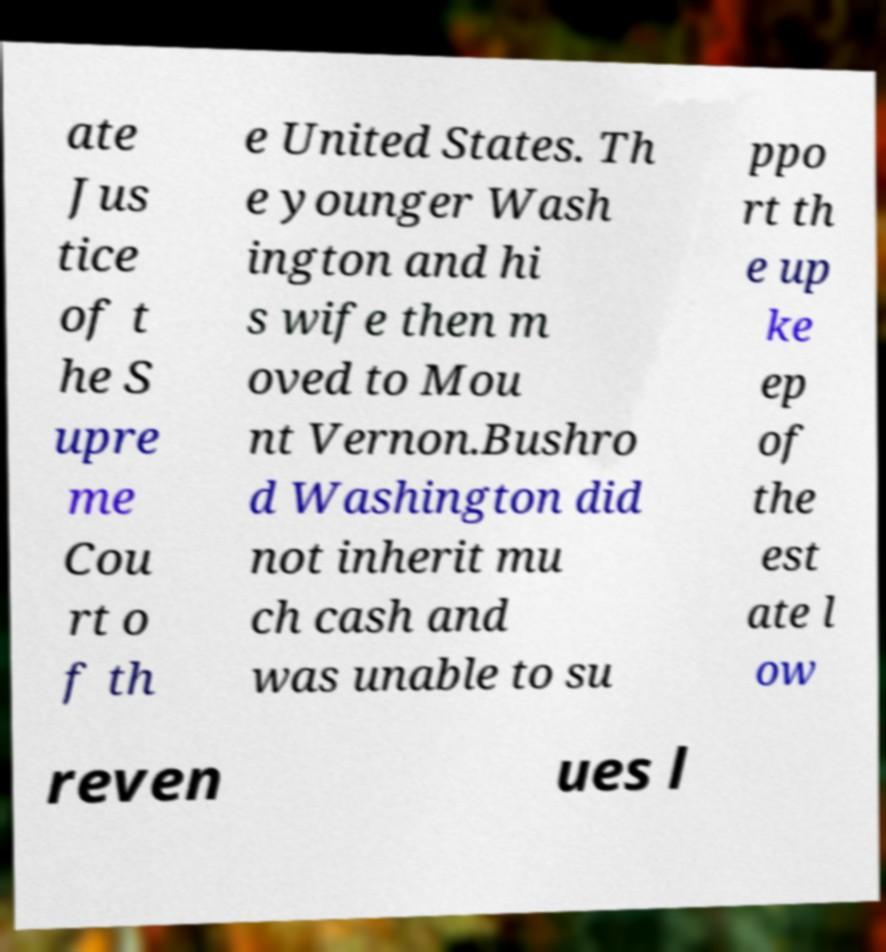There's text embedded in this image that I need extracted. Can you transcribe it verbatim? ate Jus tice of t he S upre me Cou rt o f th e United States. Th e younger Wash ington and hi s wife then m oved to Mou nt Vernon.Bushro d Washington did not inherit mu ch cash and was unable to su ppo rt th e up ke ep of the est ate l ow reven ues l 